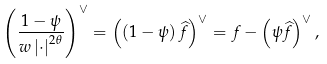Convert formula to latex. <formula><loc_0><loc_0><loc_500><loc_500>\left ( \frac { 1 - \psi } { w \left | \cdot \right | ^ { 2 \theta } } \right ) ^ { \vee } = \left ( \left ( 1 - \psi \right ) \widehat { f } \right ) ^ { \vee } = f - \left ( \psi \widehat { f } \right ) ^ { \vee } ,</formula> 